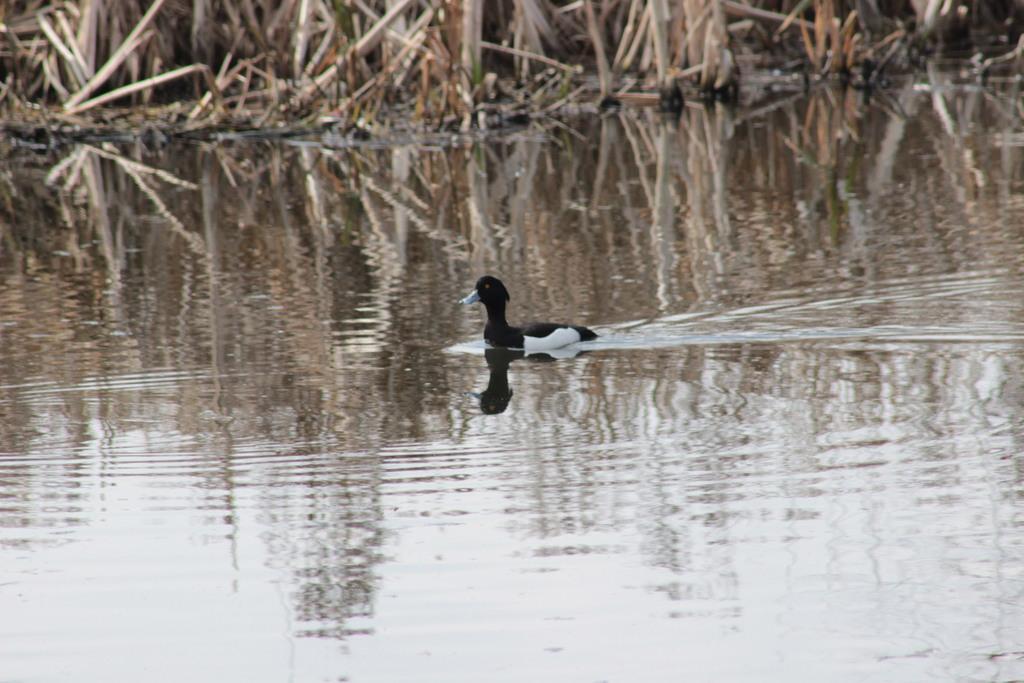Could you give a brief overview of what you see in this image? In this image I see a which is of white and black in color and I see the water. In the background I see the plants. 